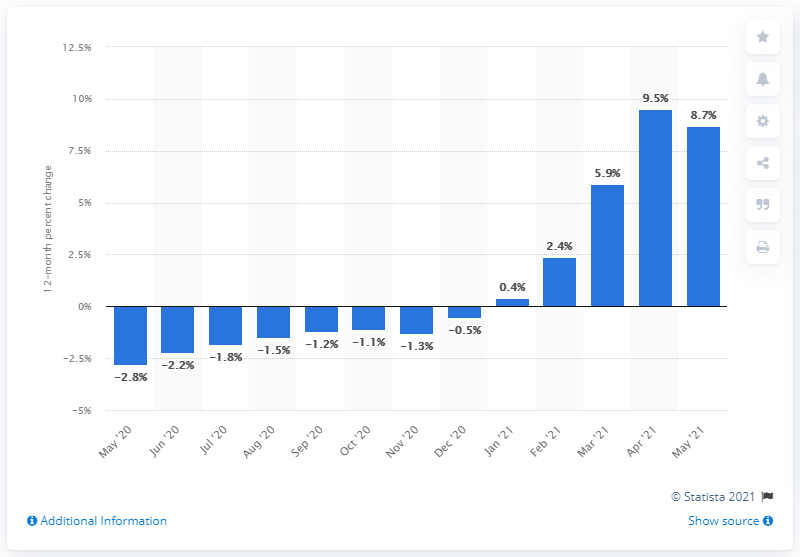Outline some significant characteristics in this image. The Producer Price Index (PPI) for finished goods increased by 8.7% in May 2021. 